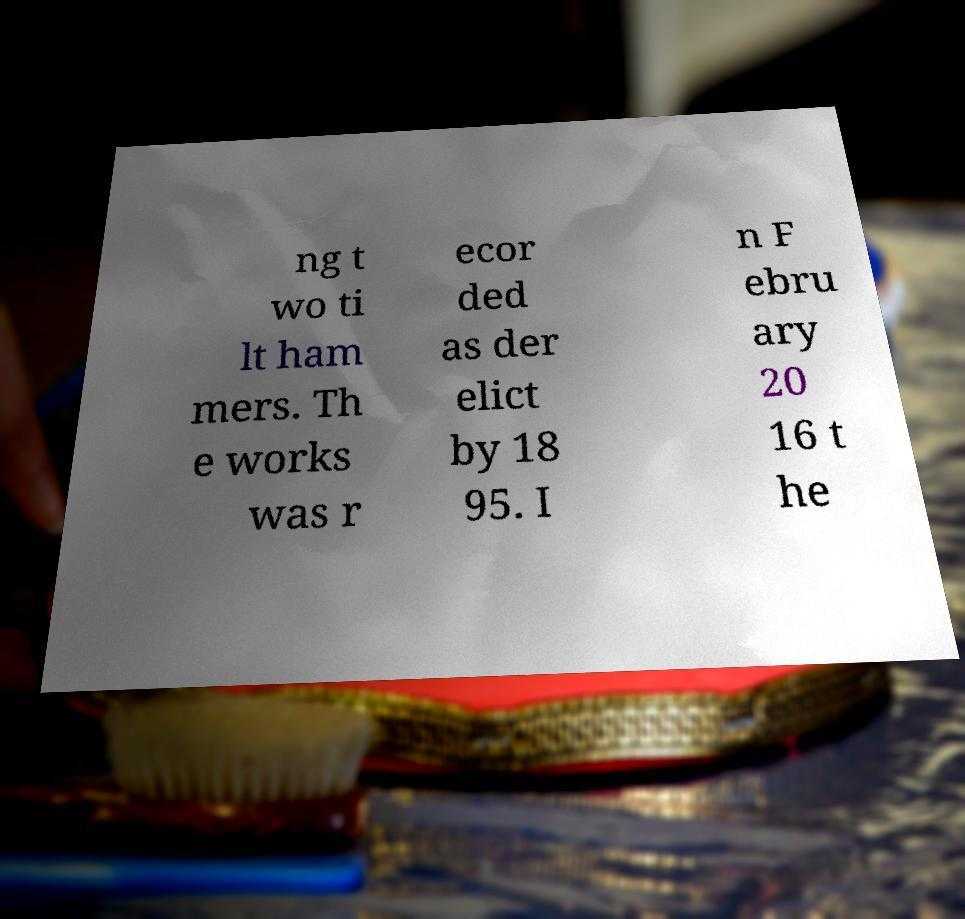Please identify and transcribe the text found in this image. ng t wo ti lt ham mers. Th e works was r ecor ded as der elict by 18 95. I n F ebru ary 20 16 t he 